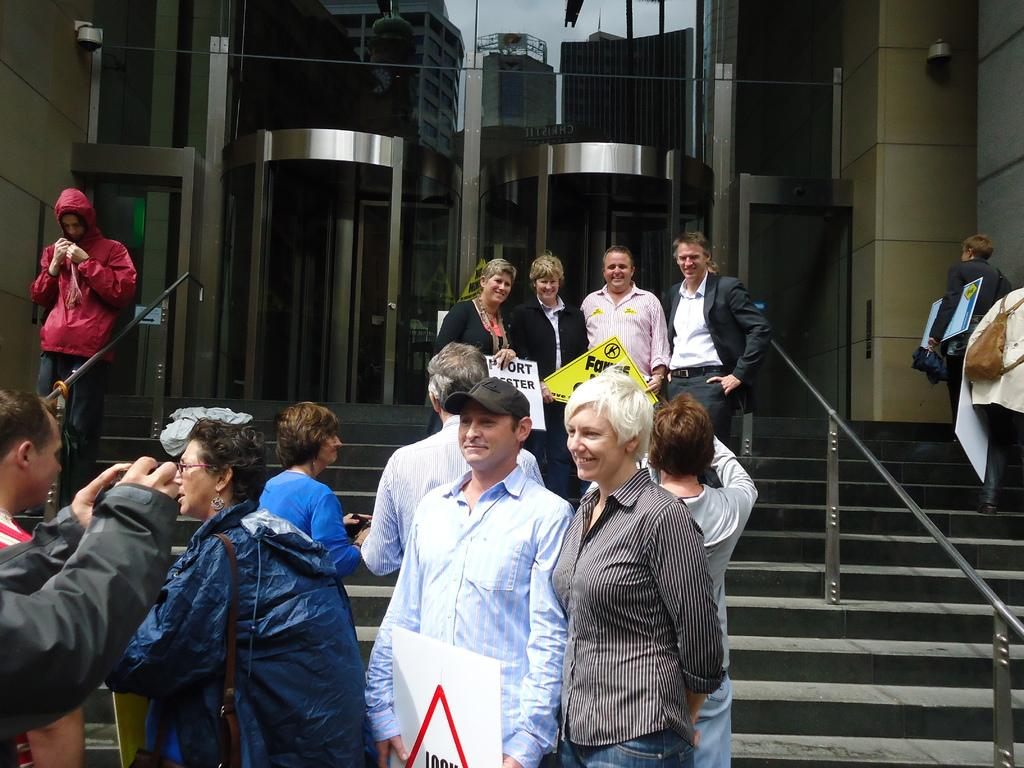What are the people in the image doing on the steps? The people in the image are standing on the steps and holding posters. What else are the people doing in the image? The people are also taking pictures. What can be seen in the background of the image? There is a building in the background of the image. What type of stew is being served at the event in the image? There is no event or stew present in the image; it only shows people standing on steps with posters and taking pictures. Can you tell me how many porters are assisting with the event in the image? There is no event or porters present in the image; it only shows people standing on steps with posters and taking pictures. 